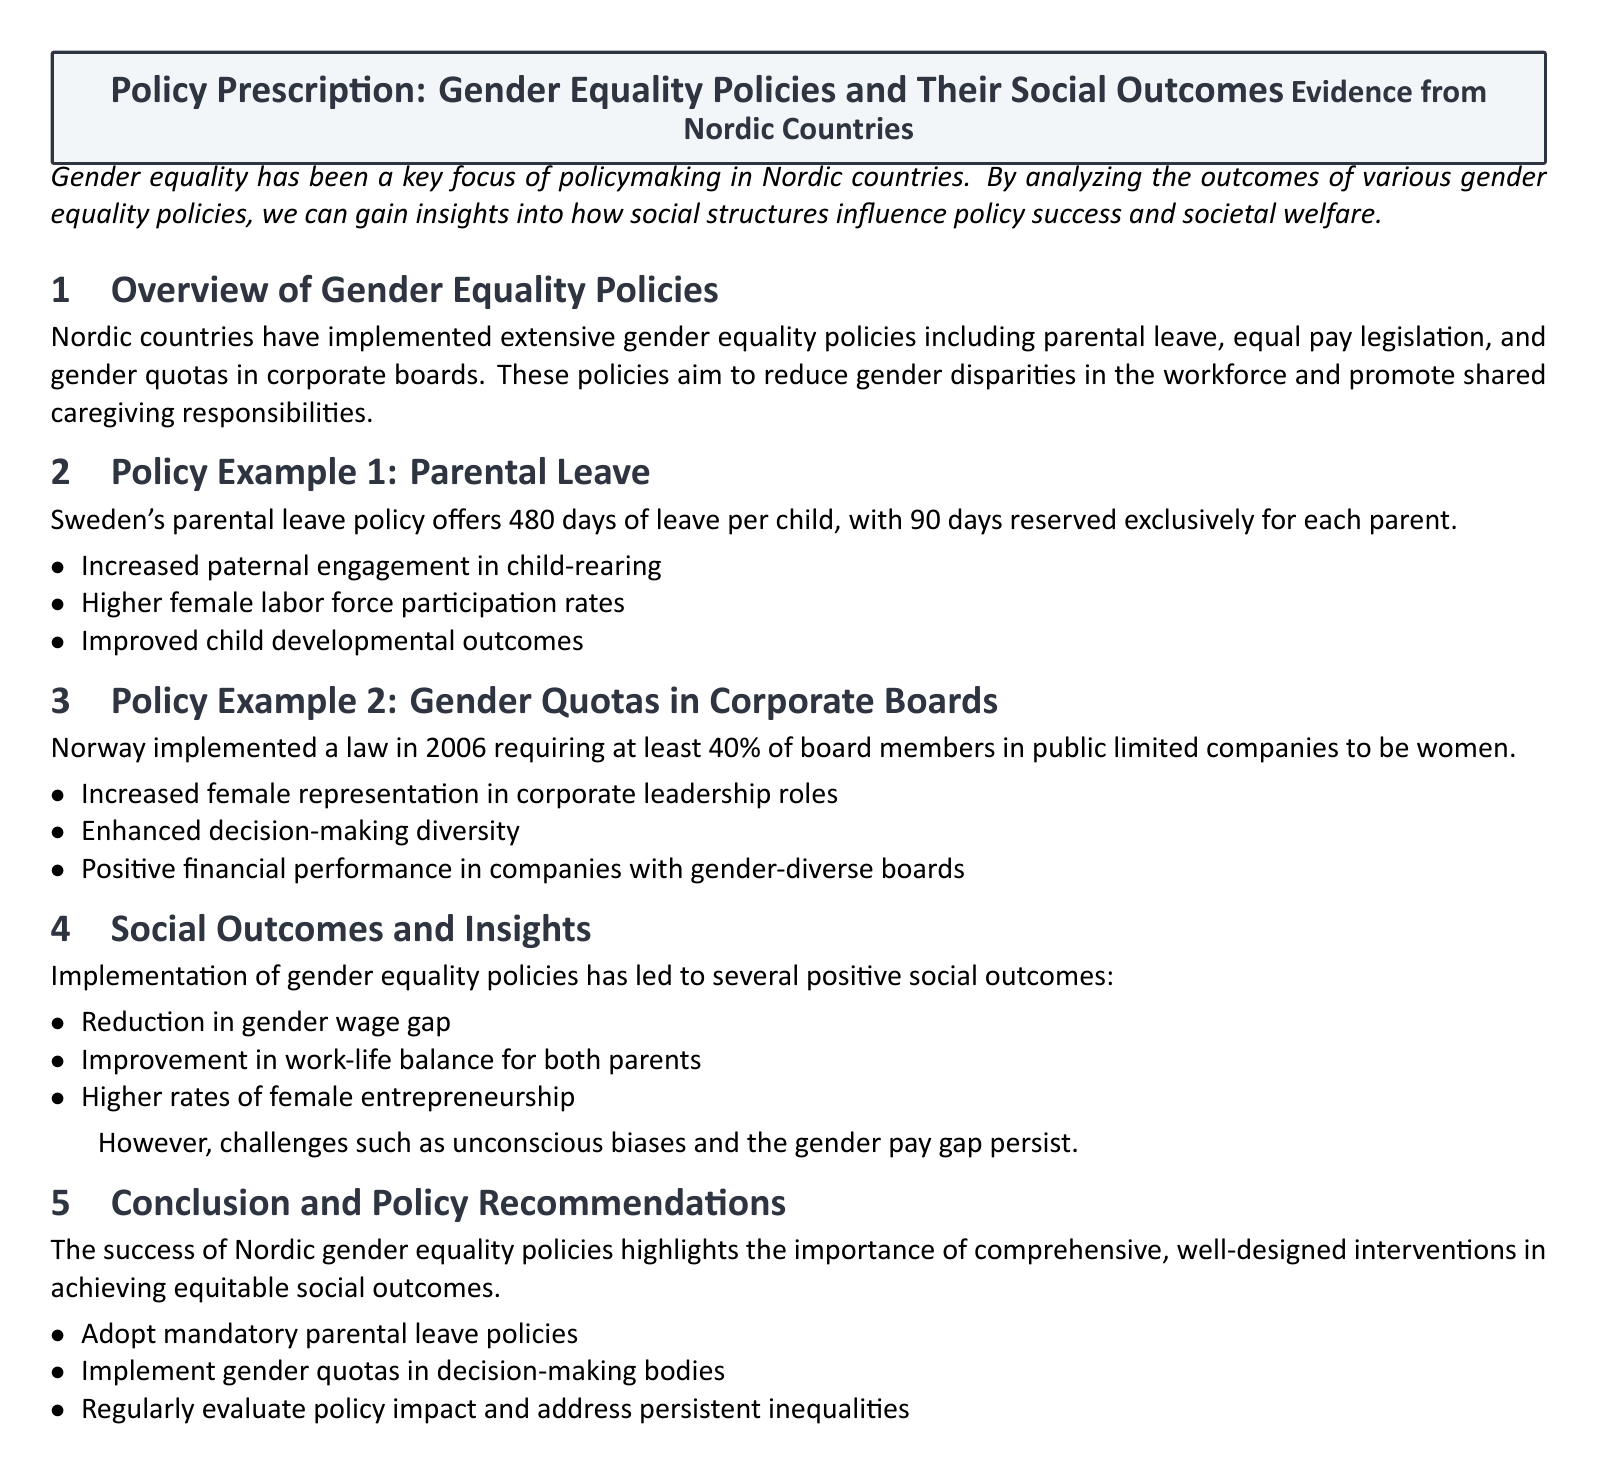What is the total number of days for parental leave in Sweden? The document states that Sweden's parental leave policy offers 480 days of leave per child.
Answer: 480 days What percentage of board members in Norway's public limited companies must be women? According to the document, Norway's law requires at least 40% of board members in public limited companies to be women.
Answer: 40% Name one positive outcome achieved by Sweden's parental leave policy. The document lists increased paternal engagement in child-rearing as a positive outcome.
Answer: Increased paternal engagement What are two challenges mentioned that persist despite gender equality policies? The document notes that unconscious biases and the gender pay gap persist as challenges.
Answer: Unconscious biases and gender pay gap What is one policy recommendation made in the conclusion? The document recommends adopting mandatory parental leave policies.
Answer: Adopt mandatory parental leave policies How many days of parental leave are reserved exclusively for each parent in Sweden? The document states that 90 days are reserved exclusively for each parent.
Answer: 90 days What document type is this content presented as? The content is structured as a policy prescription focusing on gender equality policies.
Answer: Policy prescription What is one social outcome of gender equality policies highlighted in the document? The document mentions the reduction in the gender wage gap as a social outcome.
Answer: Reduction in gender wage gap 